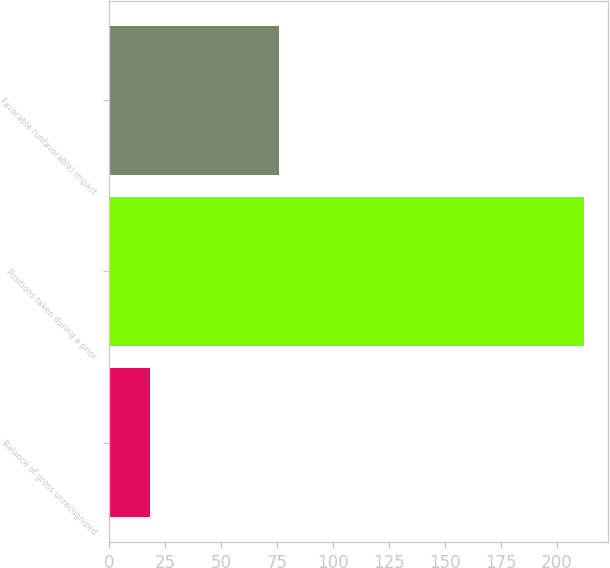Convert chart. <chart><loc_0><loc_0><loc_500><loc_500><bar_chart><fcel>Balance of gross unrecognized<fcel>Positions taken during a prior<fcel>Favorable (unfavorable) impact<nl><fcel>18<fcel>212<fcel>76<nl></chart> 